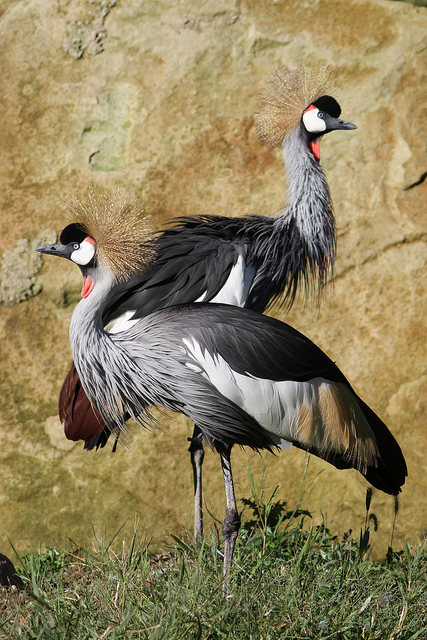<image>What type of bird are these? I am not sure what type of bird these are. The options could be 'killdeer', 'geese', 'quail', 'storks', 'grey crowned crane', 'ostrich', 'flamingo', 'ostriches', 'swan'. What type of bird are these? I am not sure what type of bird are these. It can be seen 'killdeer', 'geese', 'quail', 'storks', 'grey crowned crane', 'ostrich', 'flamingo', 'ostriches', or 'swan'. 